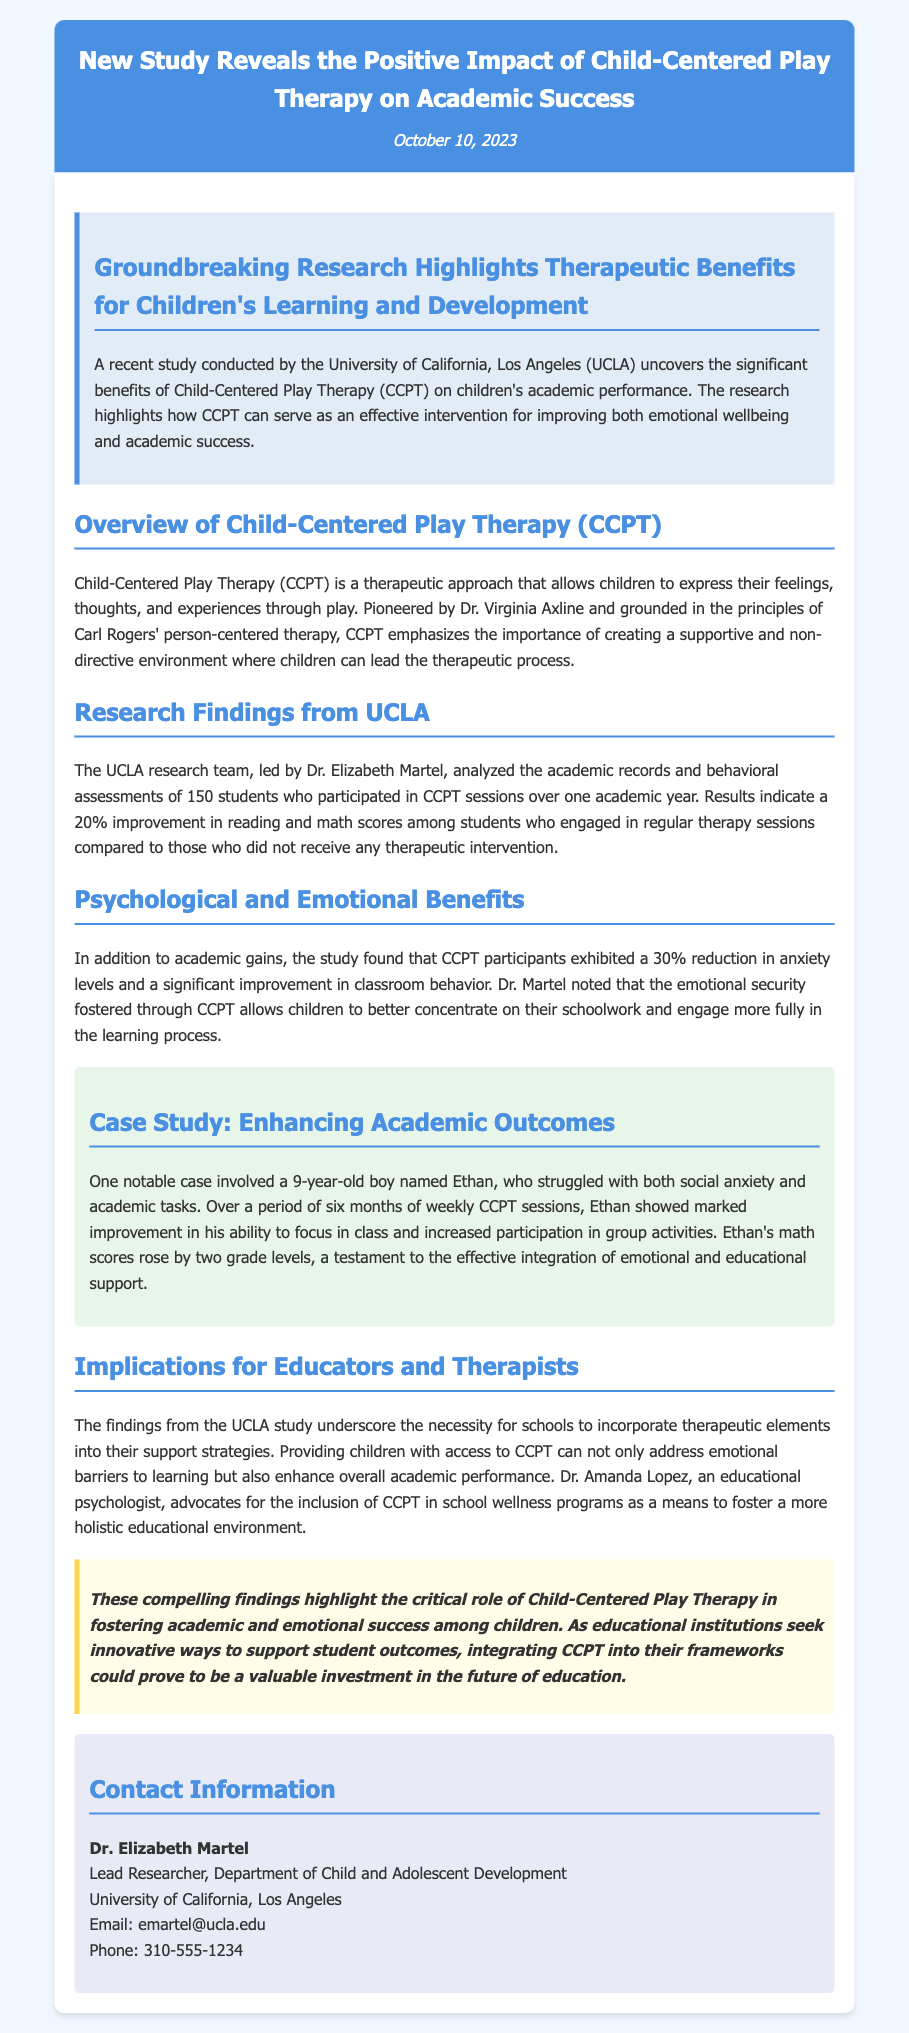What university conducted the study? The university that conducted the study is mentioned in the document as the University of California, Los Angeles (UCLA).
Answer: University of California, Los Angeles (UCLA) What is the percentage improvement in reading and math scores? The document states that there was a 20% improvement in reading and math scores among students who engaged in CCPT sessions.
Answer: 20% Who led the research team? The research team was led by Dr. Elizabeth Martel, as stated in the section detailing the research findings.
Answer: Dr. Elizabeth Martel What was the reduction in anxiety levels among CCPT participants? The study found that CCPT participants exhibited a 30% reduction in anxiety levels.
Answer: 30% What is the name of the 9-year-old boy in the case study? The case study provides the name of the boy as Ethan, who struggled with social anxiety and academic tasks.
Answer: Ethan What does CCPT stand for? The document defines CCPT as Child-Centered Play Therapy, clearly indicated in the overview section.
Answer: Child-Centered Play Therapy What did Dr. Amanda Lopez advocate for? Dr. Amanda Lopez advocates for the inclusion of CCPT in school wellness programs according to the implications section.
Answer: Inclusion of CCPT What is the date of the press release? The date of the press release is provided in the header of the document as October 10, 2023.
Answer: October 10, 2023 What significant benefits does the study highlight? The study highlights the significant benefits of CCPT for improving emotional wellbeing and academic success, as mentioned in the introduction.
Answer: Emotional wellbeing and academic success 